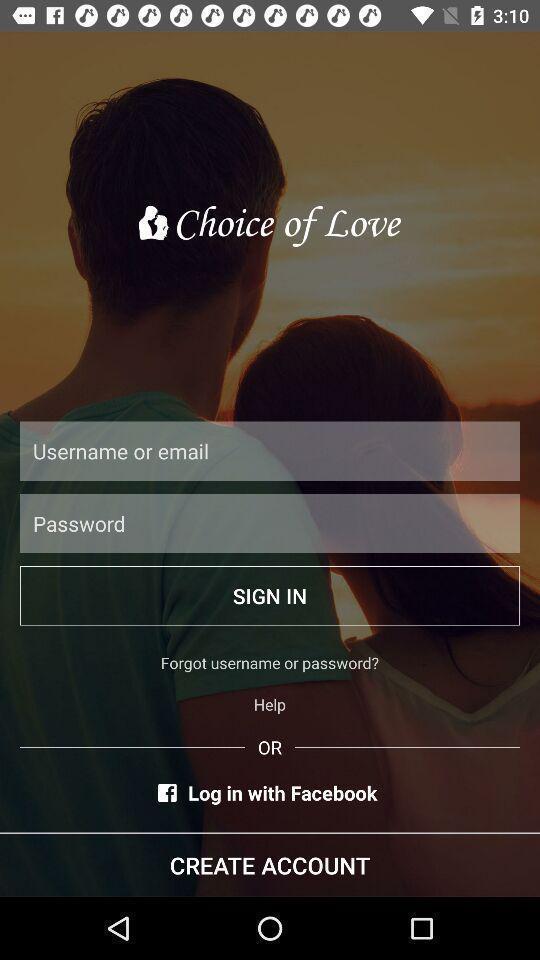What is the overall content of this screenshot? Sign in page. 